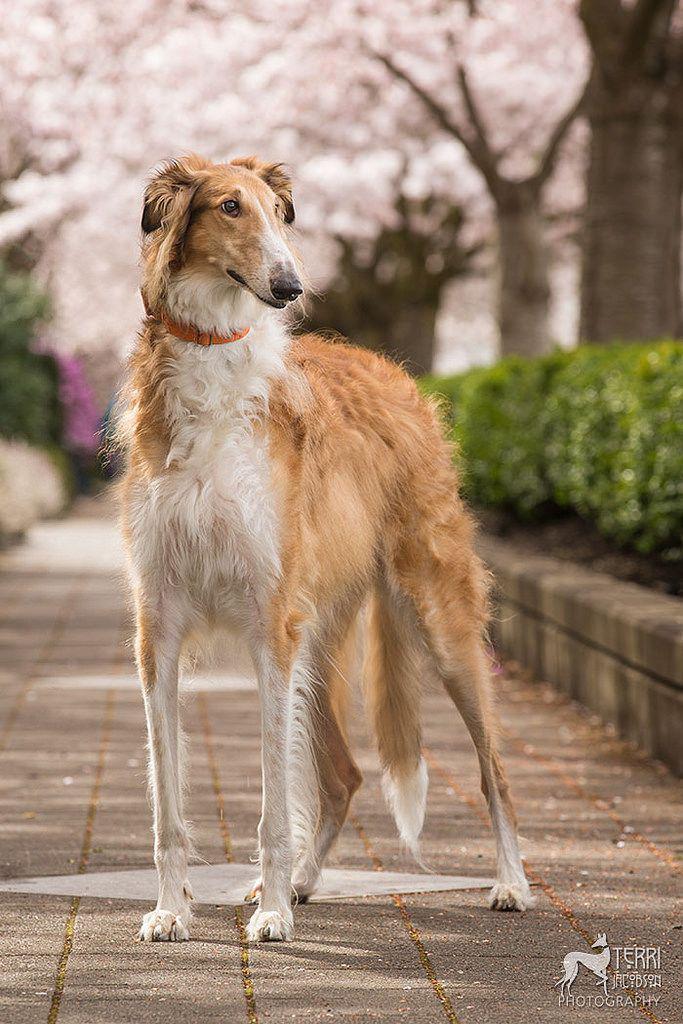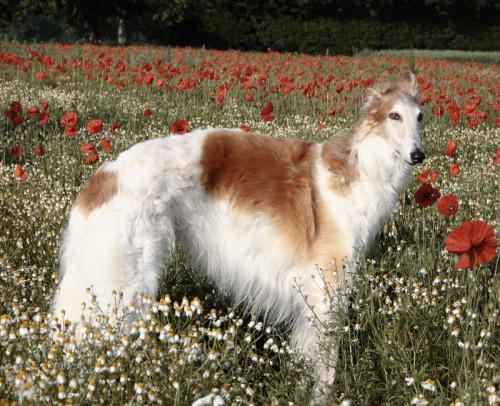The first image is the image on the left, the second image is the image on the right. Given the left and right images, does the statement "A dog is standing in a field in the image on the right." hold true? Answer yes or no. Yes. The first image is the image on the left, the second image is the image on the right. For the images shown, is this caption "The dog in the left image is standing on the sidewalk." true? Answer yes or no. Yes. 